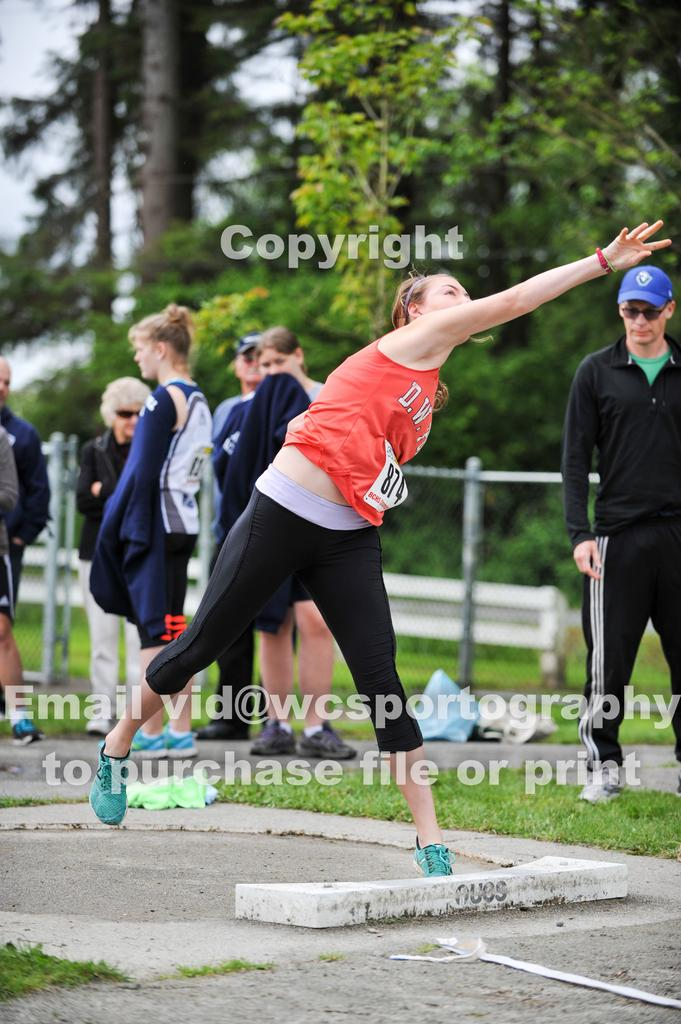What are the people in the image doing? The people in the image are standing on the ground. What type of vegetation can be seen in the image? There is grass visible in the image. What can be seen in the background of the image? There are trees and the sky visible in the background of the image. How many frogs are sitting on the sign in the image? There are no frogs or signs present in the image. 